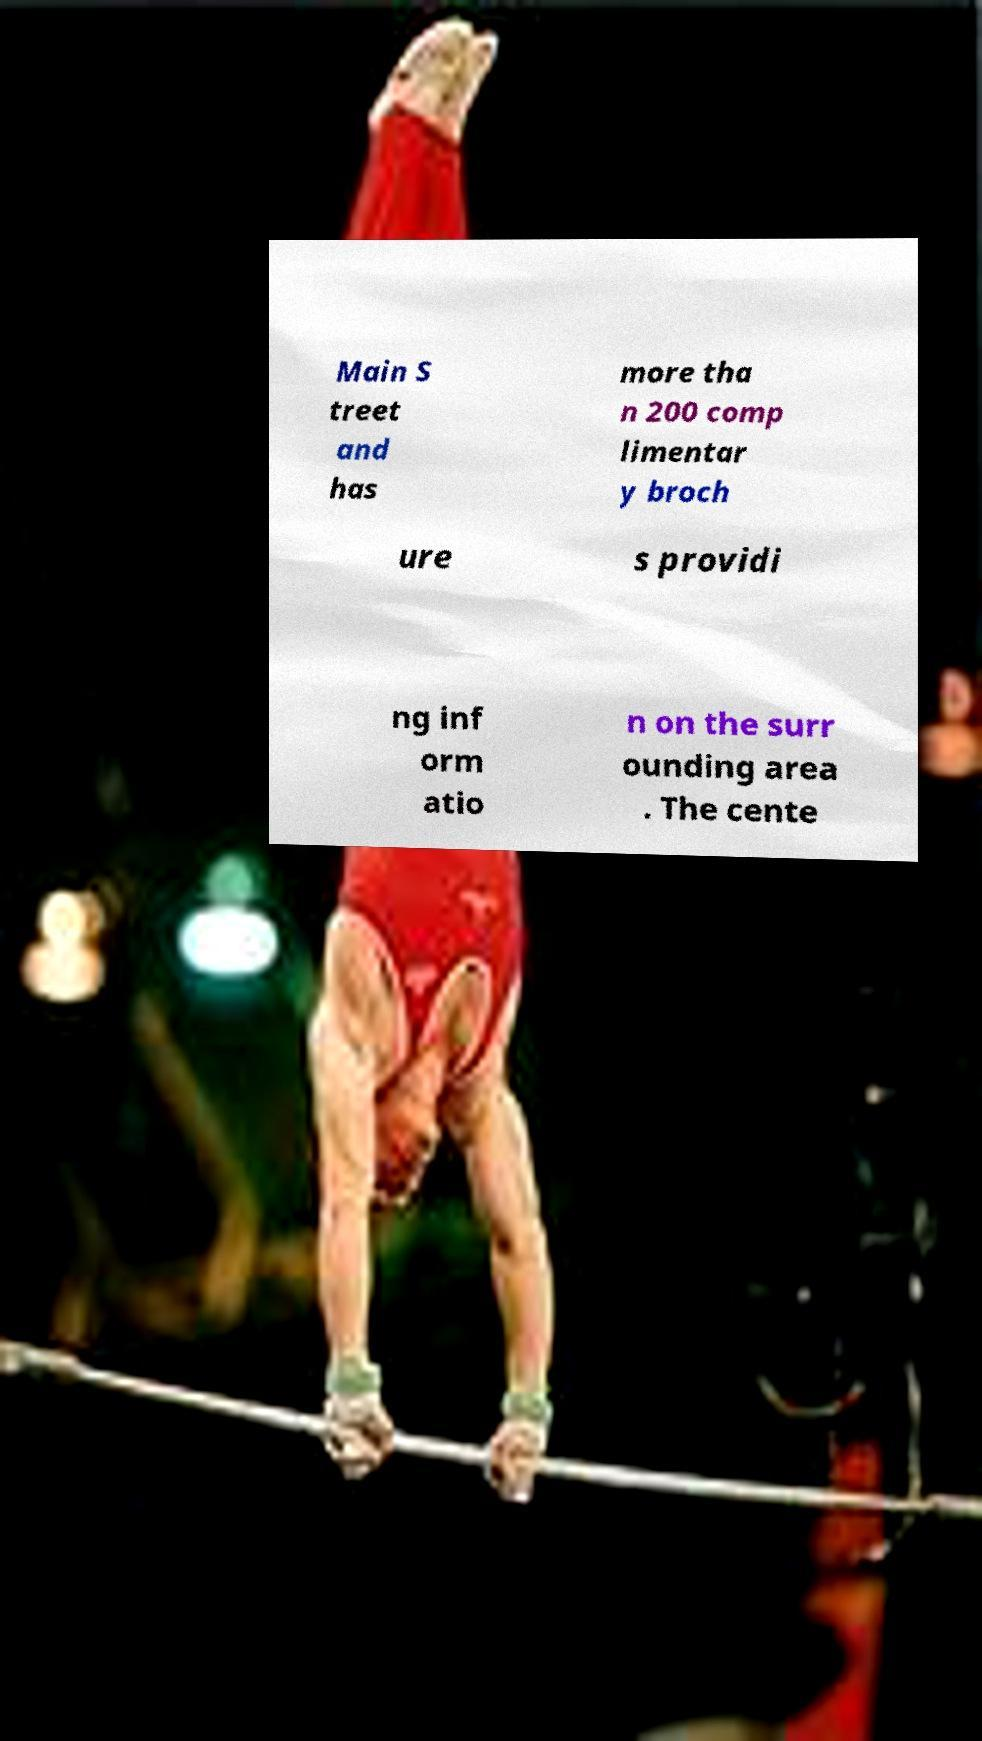What messages or text are displayed in this image? I need them in a readable, typed format. Main S treet and has more tha n 200 comp limentar y broch ure s providi ng inf orm atio n on the surr ounding area . The cente 